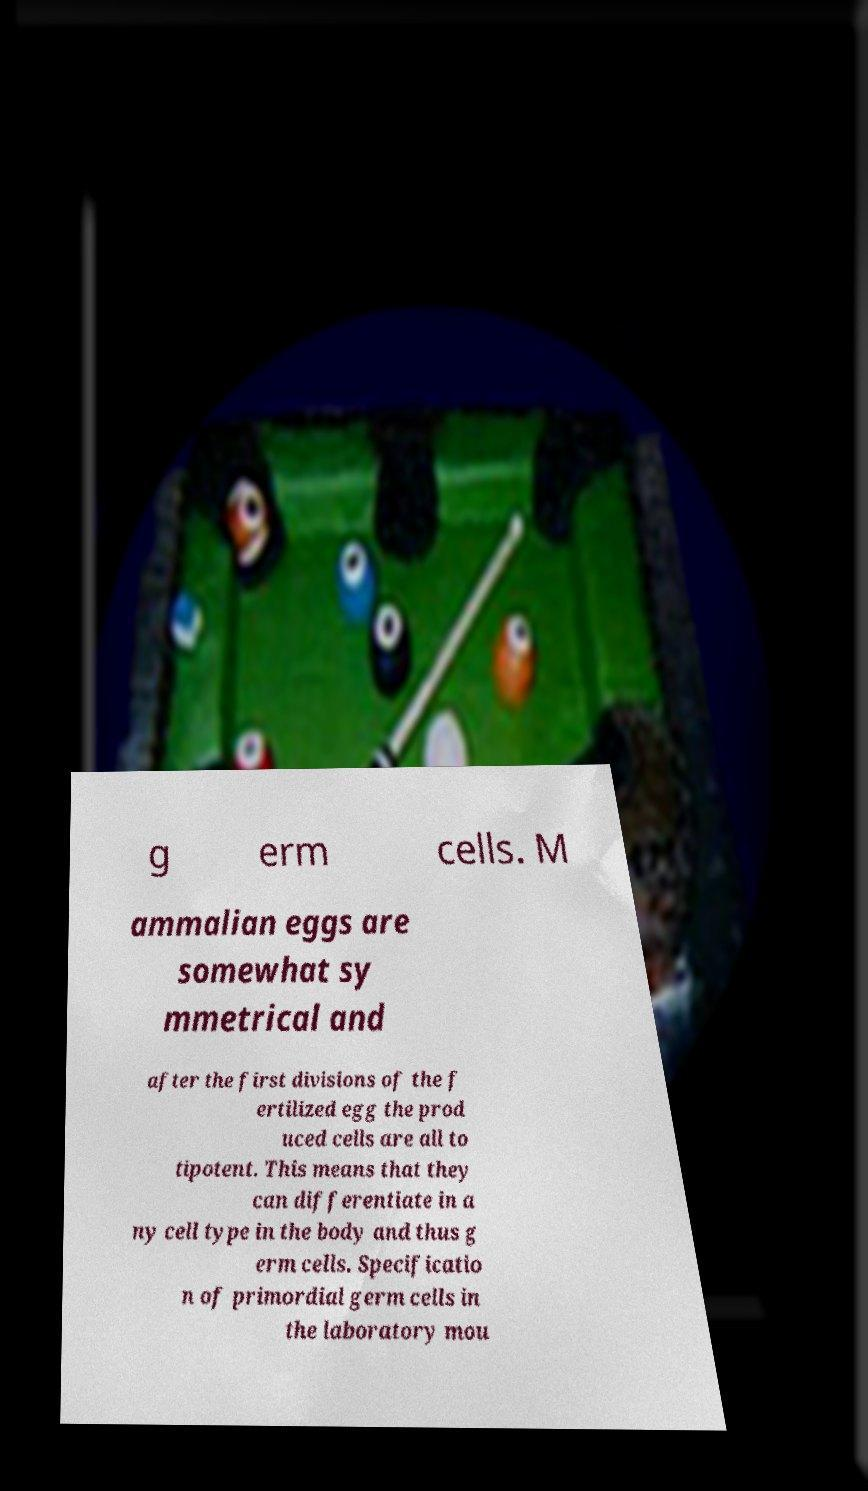I need the written content from this picture converted into text. Can you do that? g erm cells. M ammalian eggs are somewhat sy mmetrical and after the first divisions of the f ertilized egg the prod uced cells are all to tipotent. This means that they can differentiate in a ny cell type in the body and thus g erm cells. Specificatio n of primordial germ cells in the laboratory mou 